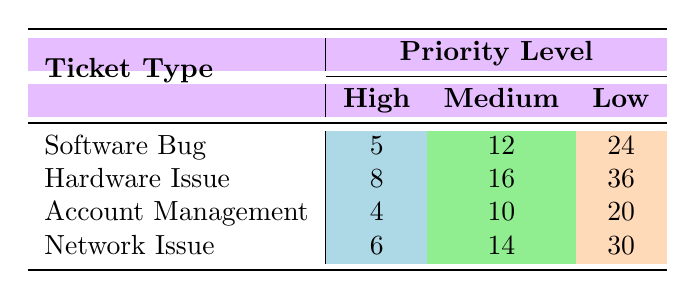What's the average resolution time for a Software Bug with High priority? The table shows that the average resolution time for a Software Bug marked as High priority is 5 hours.
Answer: 5 What is the average resolution time for Hardware Issues across all priority levels? To find the average resolution time for Hardware Issues, we sum the times for all priority levels: 8 (High) + 16 (Medium) + 36 (Low) = 60. Then we divide by 3 (the number of priority levels), so 60/3 = 20 hours.
Answer: 20 Is the average resolution time for Account Management tickets higher than that for Network Issues? The average resolution time for Account Management with High, Medium, and Low priorities is 4, 10, and 20 hours, respectively, while for Network Issues, it is 6, 14, and 30 hours. Since all resolution times for Network Issues are greater than those for Account Management, the statement is false.
Answer: No Which ticket type has the lowest average resolution time for Medium priority? The average resolution times for Medium priority are: Software Bug (12), Hardware Issue (16), Account Management (10), and Network Issue (14). The lowest time is from Account Management with 10 hours.
Answer: Account Management How much longer does it take, on average, to resolve a Low priority Software Bug compared to a Low priority Network Issue? The average resolution time for Low priority Software Bug is 24 hours, while for Low priority Network Issue, it is 30 hours. To find the difference: 30 - 24 = 6 hours. Therefore, it takes 6 hours longer for a Low priority Network Issue.
Answer: 6 